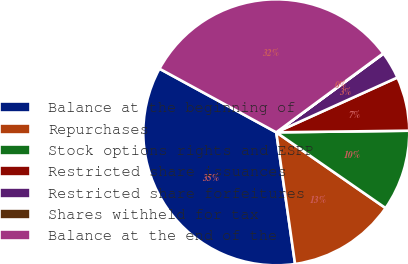<chart> <loc_0><loc_0><loc_500><loc_500><pie_chart><fcel>Balance at the beginning of<fcel>Repurchases<fcel>Stock options rights and ESPP<fcel>Restricted share issuances<fcel>Restricted share forfeitures<fcel>Shares withheld for tax<fcel>Balance at the end of the<nl><fcel>35.2%<fcel>13.1%<fcel>9.84%<fcel>6.57%<fcel>3.31%<fcel>0.05%<fcel>31.94%<nl></chart> 